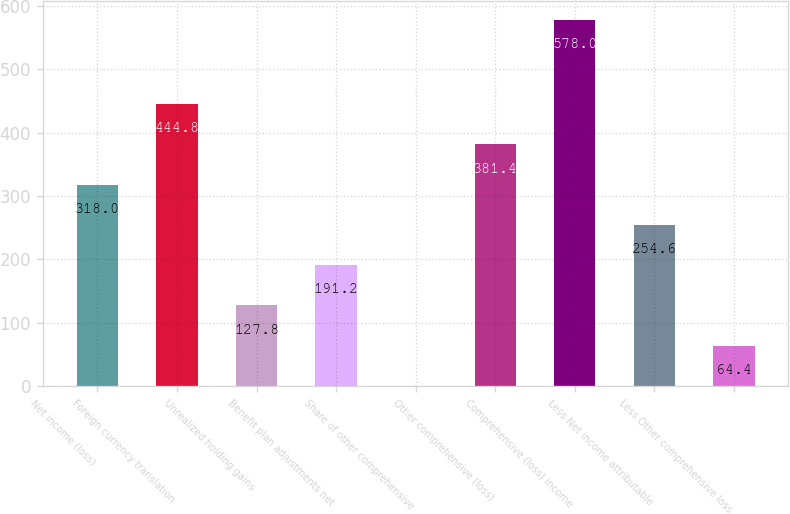Convert chart to OTSL. <chart><loc_0><loc_0><loc_500><loc_500><bar_chart><fcel>Net income (loss)<fcel>Foreign currency translation<fcel>Unrealized holding gains<fcel>Benefit plan adjustments net<fcel>Share of other comprehensive<fcel>Other comprehensive (loss)<fcel>Comprehensive (loss) income<fcel>Less Net income attributable<fcel>Less Other comprehensive loss<nl><fcel>318<fcel>444.8<fcel>127.8<fcel>191.2<fcel>1<fcel>381.4<fcel>578<fcel>254.6<fcel>64.4<nl></chart> 